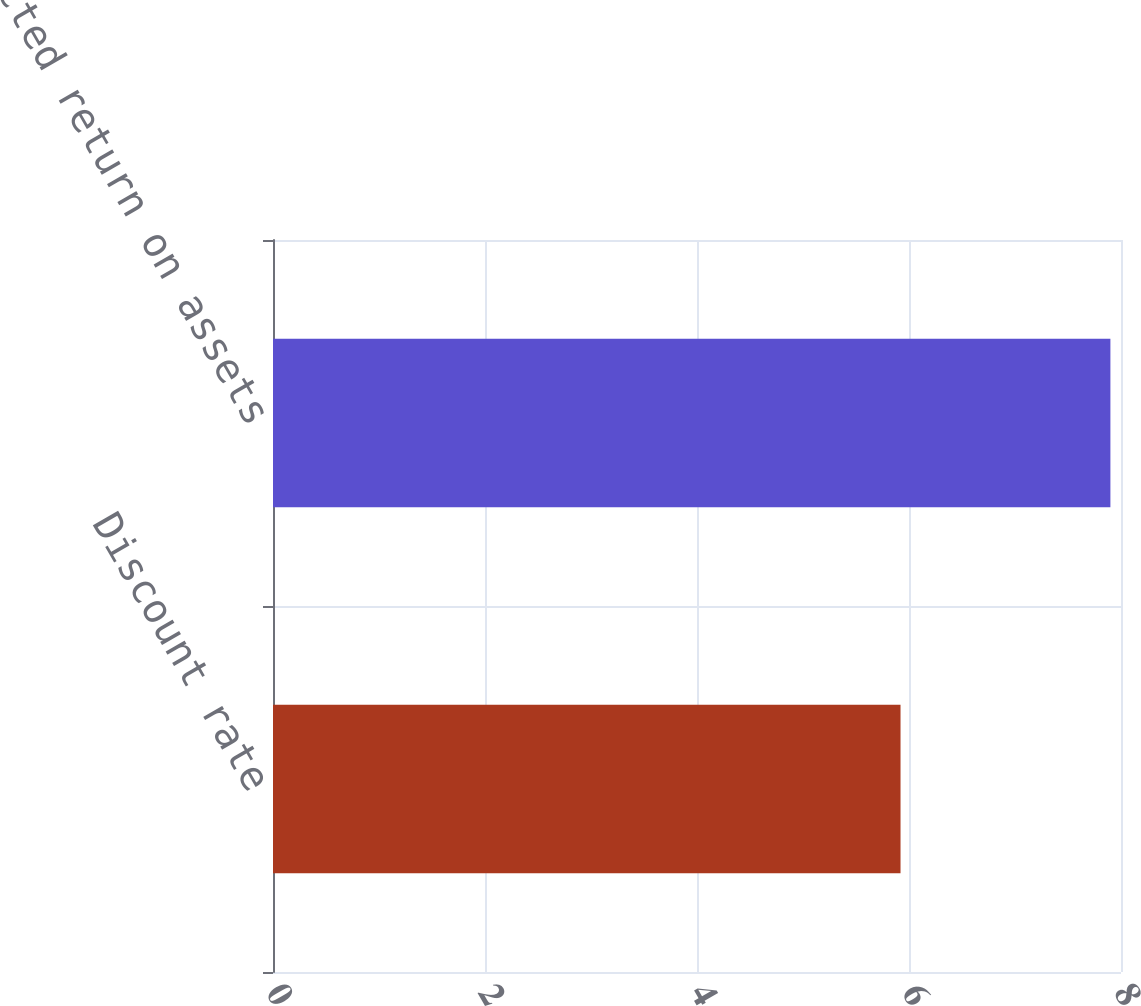<chart> <loc_0><loc_0><loc_500><loc_500><bar_chart><fcel>Discount rate<fcel>Expected return on assets<nl><fcel>5.92<fcel>7.9<nl></chart> 